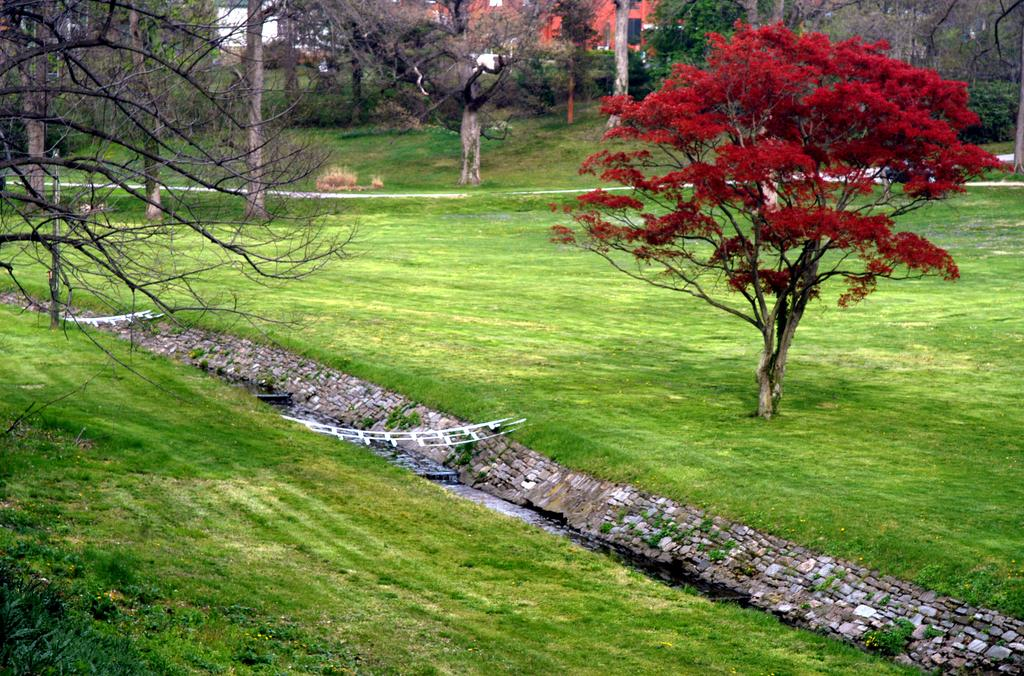Where was the image taken? The image was clicked outside. What can be seen in the middle of the image? There are trees in the middle of the image. What type of vegetation is at the bottom of the image? There is grass at the bottom of the image. What structures are visible at the top of the image? There are buildings at the top of the image. Can you see any snails crawling on the grass in the image? There is no mention of snails in the image, so we cannot determine if any are present. Is there a throne visible in the image? There is no throne present in the image. 